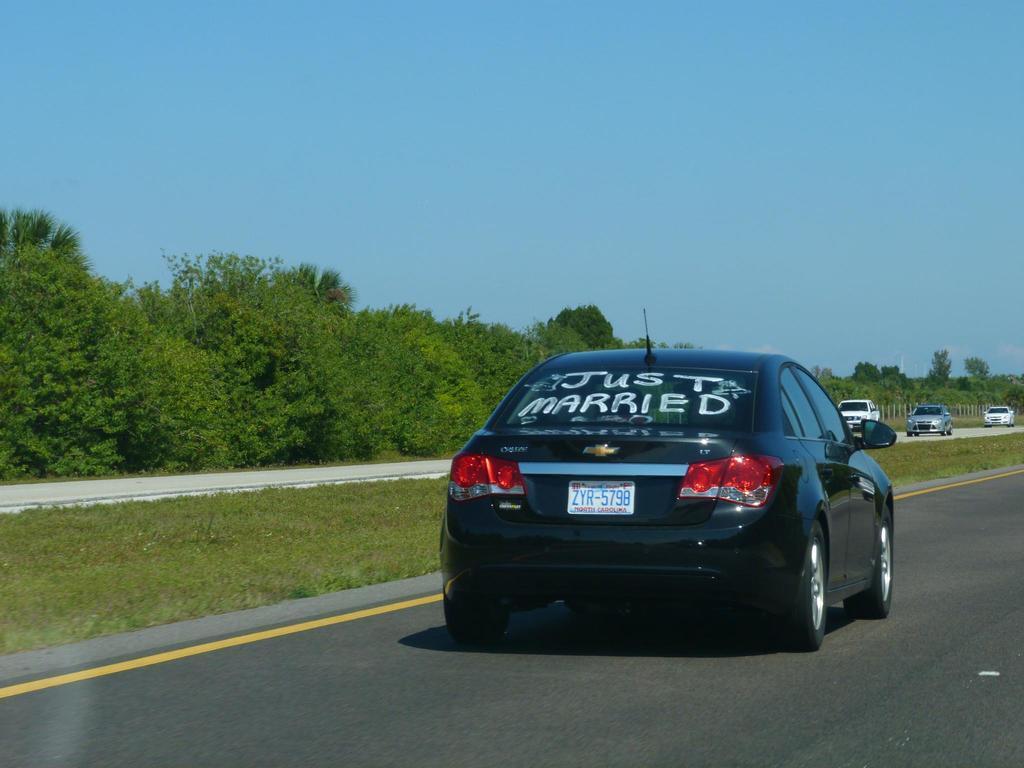In one or two sentences, can you explain what this image depicts? In this image I can see few vehicles on the road. They are in black,ash and white color. I can see a number plate,lights,mirror and something is written on the glass. Back I can see trees. The sky is in blue color. 